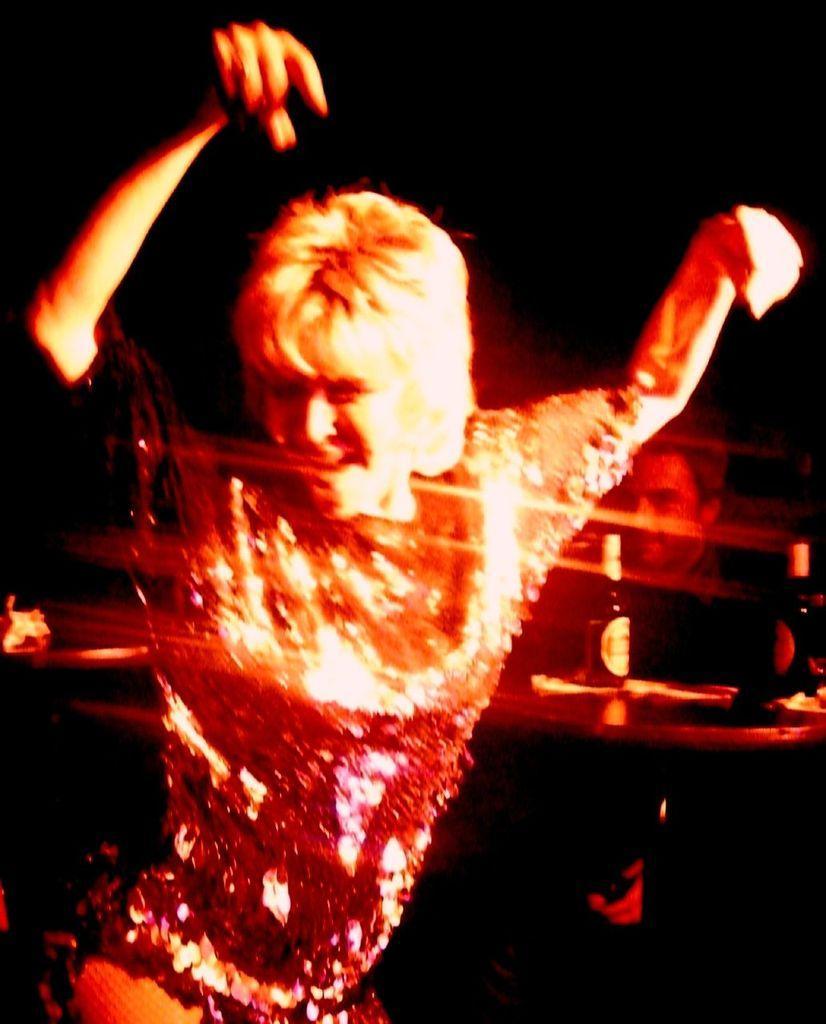How would you summarize this image in a sentence or two? In this image we can see a person is dancing. On the right side of the image, we can see a man, table and bottles. The background is dark. 